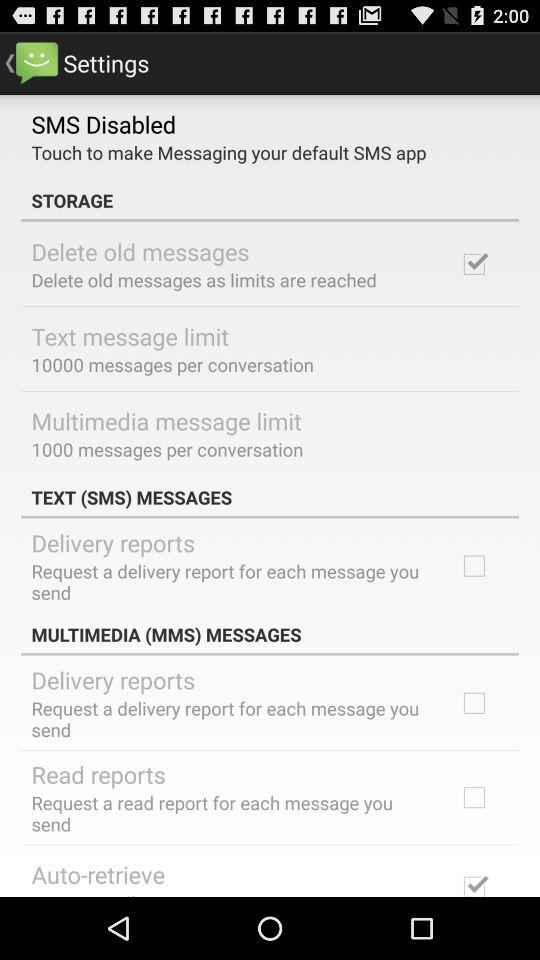What is the status of "Delivery reports" in "TEXT MESSAGES"? The status of "Delivery reports" in "TEXT MESSAGES" is "off". 